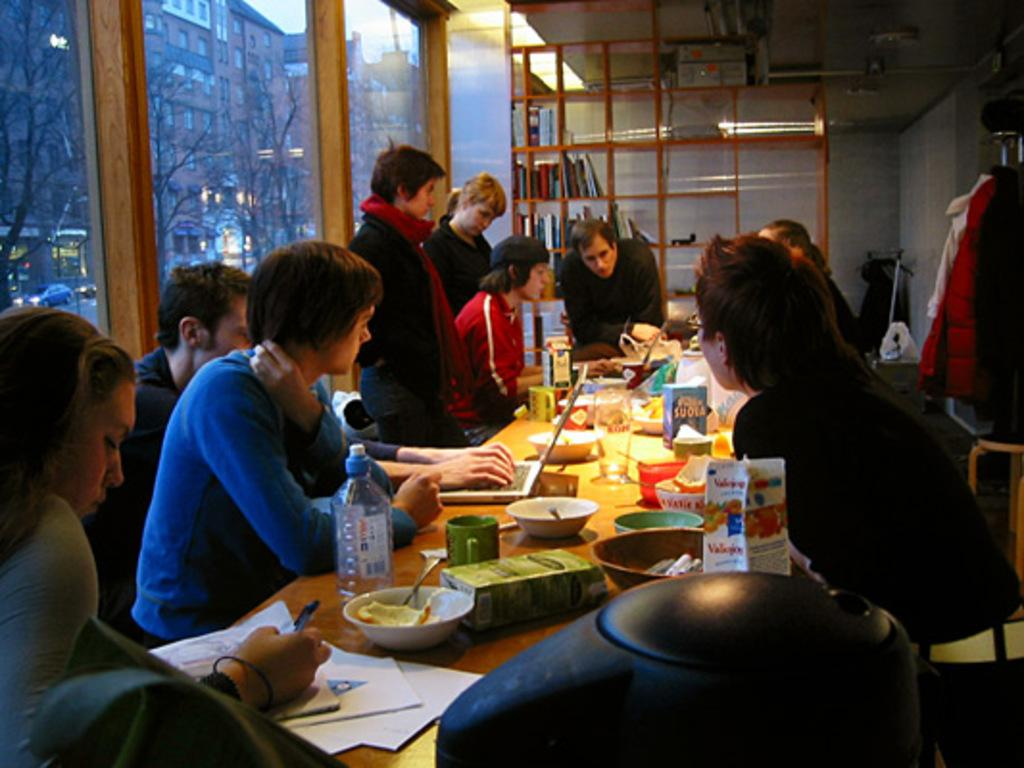What is the main subject of the image? The main subject of the image is a group of people. What are the people doing in the image? The people are sitting around a table. What can be seen on the table in the image? There is food material on the table. What else is visible in the image besides the people and the table? There are books on a rack beside the table. What type of sugar is being used to sweeten the plot in the image? There is no sugar or plot present in the image; it features a group of people sitting around a table with food material and books on a rack. 